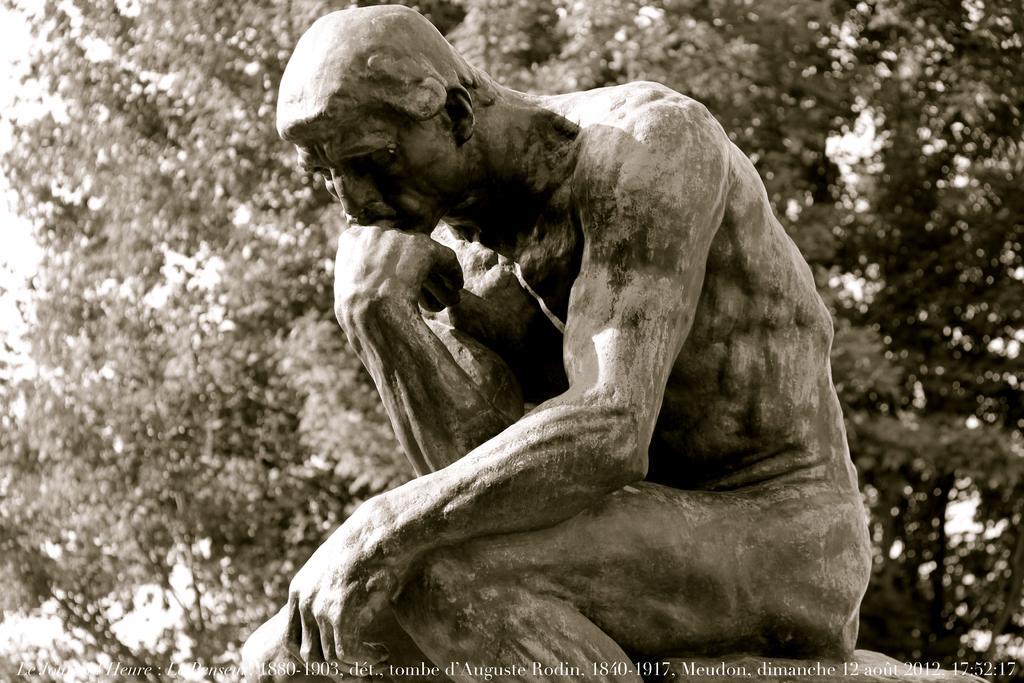Please provide a concise description of this image. In this image I can see a sculpture in the front and in the background I can see few trees. I can also see a watermark on the bottom side of this image. 